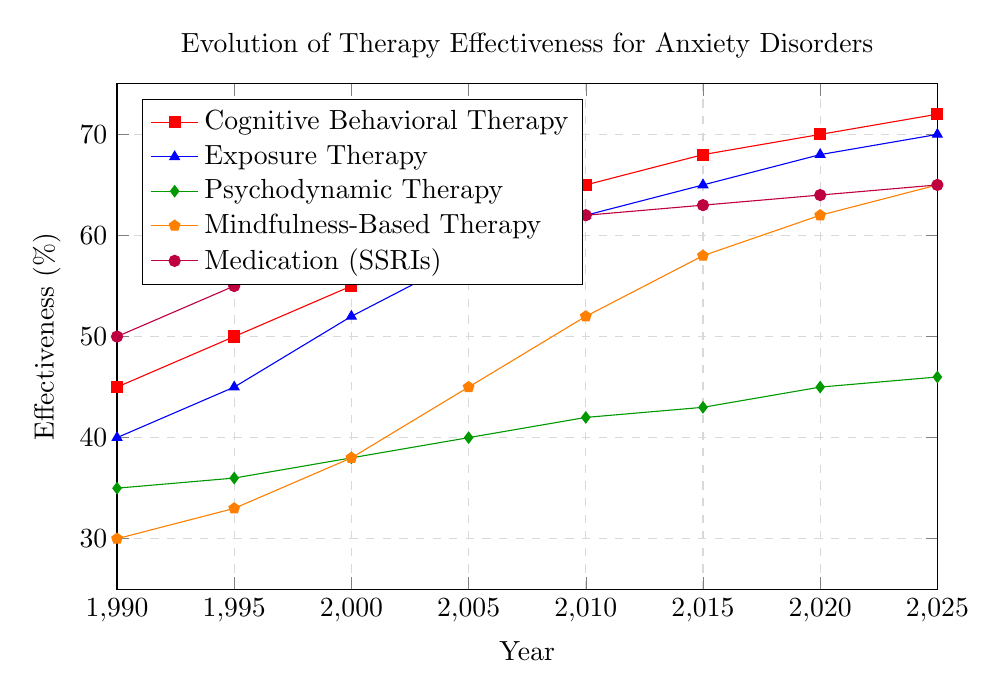What is the effectiveness of Cognitive Behavioral Therapy in 2010 compared to Exposure Therapy in the same year? The effectiveness of Cognitive Behavioral Therapy in 2010 is 65%, and the effectiveness of Exposure Therapy in 2010 is 62%. Comparing the two values, Cognitive Behavioral Therapy is 3% more effective than Exposure Therapy in 2010.
Answer: 3% Which therapy showed the most improvement in effectiveness from 1990 to 2025? To determine the most improvement, we calculate the difference in effectiveness from 1990 to 2025 for each therapy: 
- Cognitive Behavioral Therapy: 72% - 45% = 27%
- Exposure Therapy: 70% - 40% = 30%
- Psychodynamic Therapy: 46% - 35% = 11%
- Mindfulness-Based Therapy: 65% - 30% = 35%
- Medication (SSRIs): 65% - 50% = 15%
Mindfulness-Based Therapy showed the most improvement with an increase of 35%.
Answer: Mindfulness-Based Therapy Between 2005 and 2015, which therapy exhibited the largest increase in effectiveness? To find the largest increase, we calculate the difference in effectiveness between 2005 and 2015 for each therapy:
- Cognitive Behavioral Therapy: 68% - 60% = 8%
- Exposure Therapy: 65% - 58% = 7%
- Psychodynamic Therapy: 43% - 40% = 3%
- Mindfulness-Based Therapy: 58% - 45% = 13%
- Medication (SSRIs): 63% - 60% = 3%
Mindfulness-Based Therapy exhibited the largest increase with 13%.
Answer: Mindfulness-Based Therapy Which therapy was the least effective in 1990, and how much did its effectiveness improve by 2020? In 1990, Mindfulness-Based Therapy had the lowest effectiveness at 30%. The effectiveness in 2020 is 62%. Thus, the improvement is 62% - 30% = 32%.
Answer: Mindfulness-Based Therapy, 32% What is the average effectiveness of Psychodynamic Therapy over the years listed in the data? To find the average, sum the effectiveness values for Psychodynamic Therapy and divide by the number of years:
(35% + 36% + 38% + 40% + 42% + 43% + 45% + 46%) / 8 = 325% / 8 = 40.625%. The average effectiveness is approximately 40.6%.
Answer: 40.6% How many years did Cognitive Behavioral Therapy and Exposure Therapy have the same effectiveness percentage? By examining the data, we see no years where Cognitive Behavioral Therapy and Exposure Therapy have the same effectiveness percentage.
Answer: 0 years Which therapy had an effectiveness of 50% in 1990, and how did it compare with other therapies that year? In 1990, Medication (SSRIs) had an effectiveness of 50%. Compared to other therapies that year:
- Cognitive Behavioral Therapy: 45%
- Exposure Therapy: 40%
- Psychodynamic Therapy: 35%
- Mindfulness-Based Therapy: 30%
Medication (SSRIs) had the highest effectiveness in 1990.
Answer: Medication (SSRIs) Which therapies had a consistent year-over-year increase in effectiveness from 1990 to 2025? Examining the changes year-over-year:
- Cognitive Behavioral Therapy: Increases every period.
- Exposure Therapy: Increases every period.
- Psychodynamic Therapy: Increases every period.
- Mindfulness-Based Therapy: Increases every period.
- Medication (SSRIs): Increases every period.
All therapies showed a consistent year-over-year increase in effectiveness.
Answer: All therapies 